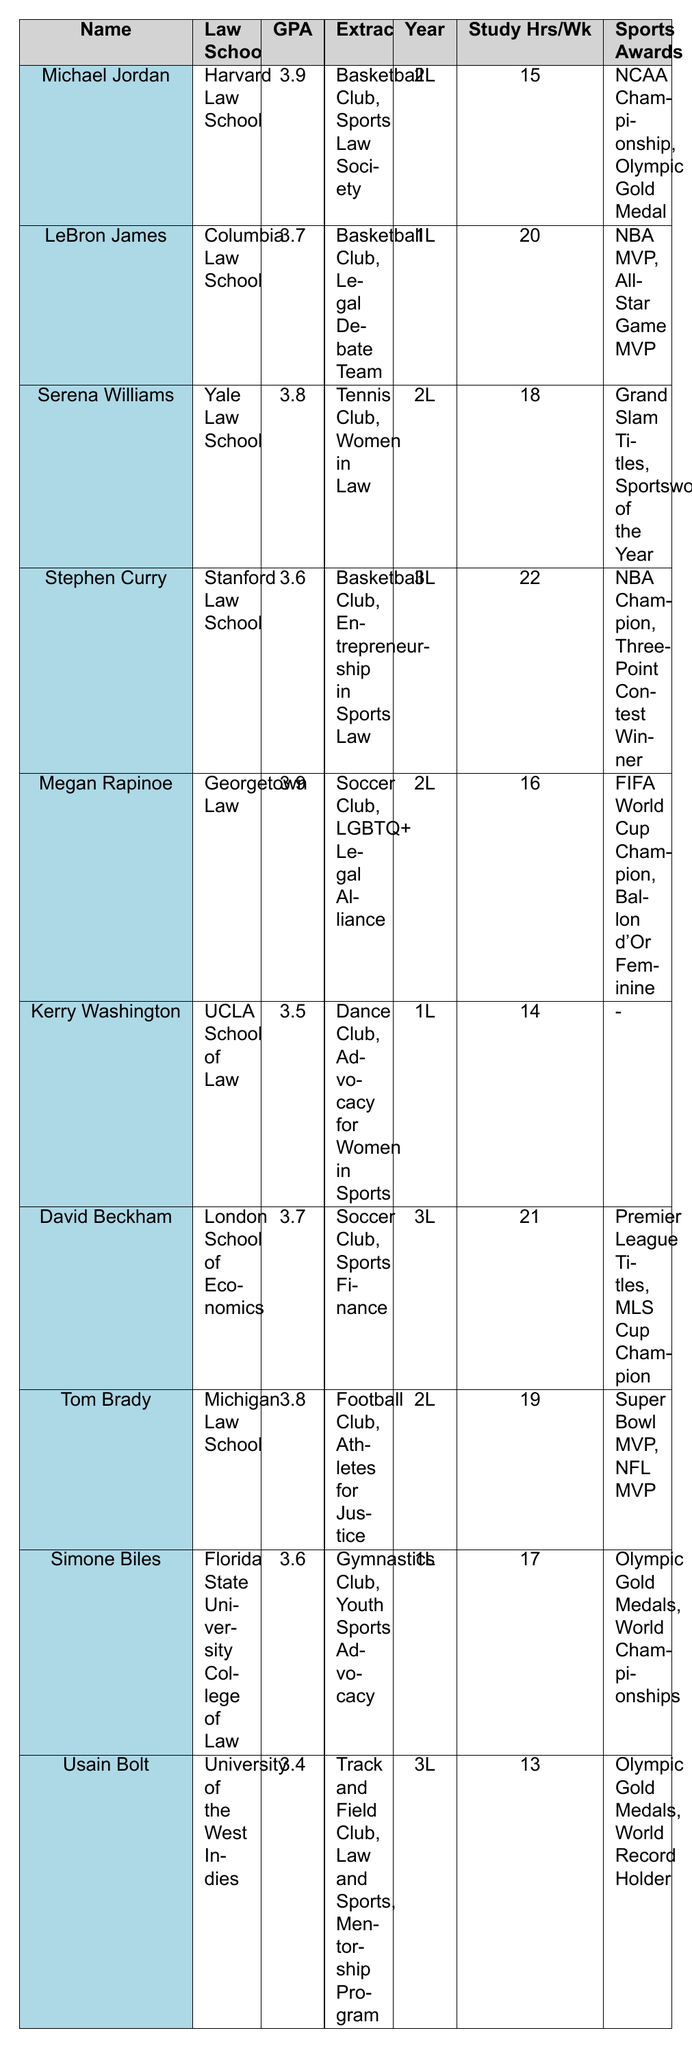What is the GPA of Michael Jordan? In the table, we locate Michael Jordan's row, which shows that his GPA is listed under that column. The GPA for Michael Jordan is 3.9.
Answer: 3.9 Which law school has the student with the highest GPA? By reviewing the GPA column, we observe that both Michael Jordan and Megan Rapinoe have the highest GPA of 3.9. Michael Jordan attends Harvard Law School.
Answer: Harvard Law School How many extracurricular activities does LeBron James participate in? In LeBron James's row, we count the extracurricular activities listed. He is involved in two: Basketball Club and Legal Debate Team.
Answer: 2 What is the average GPA of the law students listed? We first compute the sum of all GPAs: 3.9 + 3.7 + 3.8 + 3.6 + 3.9 + 3.5 + 3.7 + 3.8 + 3.6 + 3.4 = 37.4. There are 10 students, so the average is 37.4 / 10 = 3.74.
Answer: 3.74 Which 1L student has the highest GPA? Filtering for 1L students, we see that LeBron James has a GPA of 3.7, while Kerry Washington has a GPA of 3.5, and Simone Biles has a GPA of 3.6. Therefore, LeBron James has the highest GPA among the 1Ls.
Answer: LeBron James Does Usain Bolt have any sports awards? Checking the sports awards column for Usain Bolt, we find that it lists Olympic Gold Medals and World Record Holder as his achievements, indicating that he does have awards.
Answer: Yes What is the total number of study hours per week for students involved in the Basketball Club? We identify those involved in the Basketball Club: Michael Jordan (15), LeBron James (20), and Stephen Curry (22). Adding them gives 15 + 20 + 22 = 57 total study hours per week.
Answer: 57 Which student has the most sports awards? Reviewing the sports awards column, we see that Michael Jordan and Megan Rapinoe are highlighted for having notable accolades. Michael Jordan has 2 awards while Megan Rapinoe does as well. Therefore, they are tied for the most awards listed.
Answer: Michael Jordan and Megan Rapinoe What is the difference in average study hours per week between 1L and 3L students? First, we compute the average for 1L students: (20 + 17 + 14) / 3 = 17.67. For 3L students: (22 + 21 + 13) / 3 = 18.67. The difference is 18.67 - 17.67 = 1.
Answer: 1 How many students have a GPA above 3.5? We scan the GPA column and find that the following students have GPAs above 3.5: Michael Jordan (3.9), LeBron James (3.7), Serena Williams (3.8), Megan Rapinoe (3.9), Tom Brady (3.8), David Beckham (3.7), Stephen Curry (3.6), and Simone Biles (3.6). Counting these gives us a total of 8 students.
Answer: 8 